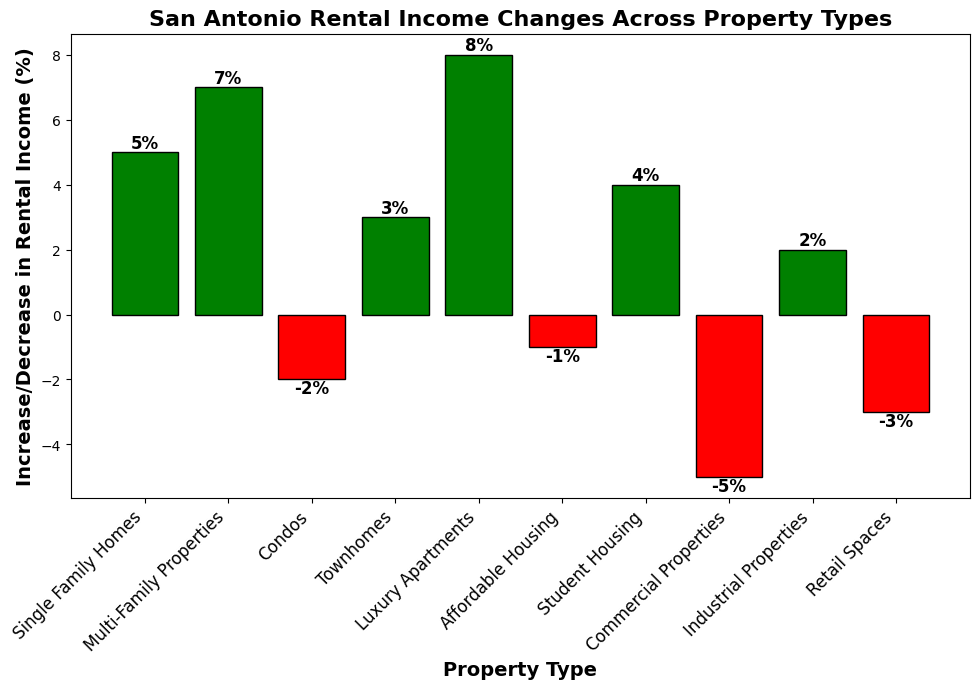Which property type had the highest rental income increase? Luxury Apartments had the highest bar height among all the property types, indicating it had the highest increase.
Answer: Luxury Apartments Which property type experienced the largest decrease in rental income? Commercial Properties had the lowest bar height, which means it experienced the largest decrease in rental income.
Answer: Commercial Properties How much did the rental income for Multi-Family Properties increase by? The bar for Multi-Family Properties shows a positive increase value of 7%, as indicated at the top of the bar.
Answer: 7% Which properties saw an increase in rental income? The positive (green) bars represent properties that saw an increase in rental income. These are Single Family Homes, Multi-Family Properties, Townhomes, Luxury Apartments, Student Housing, and Industrial Properties.
Answer: Single Family Homes, Multi-Family Properties, Townhomes, Luxury Apartments, Student Housing, Industrial Properties What's the difference in rental income changes between Retail Spaces and Single Family Homes? Retail Spaces decreased by -3% while Single Family Homes increased by 5%. The difference is calculated as 5% - (-3%) = 8%.
Answer: 8% What is the average change in rental income across all property types? Sum up all the changes: 5 + 7 - 2 + 3 + 8 - 1 + 4 - 5 + 2 - 3 = 18. Divide by the number of property types (10): 18/10 = 1.8.
Answer: 1.8% Are there more property types with an increase or a decrease in rental income? There are 6 green (positive) bars and 4 red (negative) bars. Therefore, more property types saw an increase in rental income.
Answer: Increase What is the total rental income change for residential properties (Single Family Homes, Multi-Family Properties, Condos, Townhomes, Luxury Apartments)? Add the changes for these properties: 5 + 7 - 2 + 3 + 8 = 21%
Answer: 21% What is the combined percentage rental income change for commercial and industrial properties? Commercial Properties and Industrial Properties have changes of -5% and 2% respectively. Combined, they total -5% + 2% = -3%.
Answer: -3% Between Affordable Housing and Student Housing, which experienced a rental income increase and by how much? Affordable Housing saw a -1% change, while Student Housing saw a 4% change. 4% is an increase compared to -1%. The difference is 4% - (-1%) = 5%.
Answer: Student Housing, 5% 